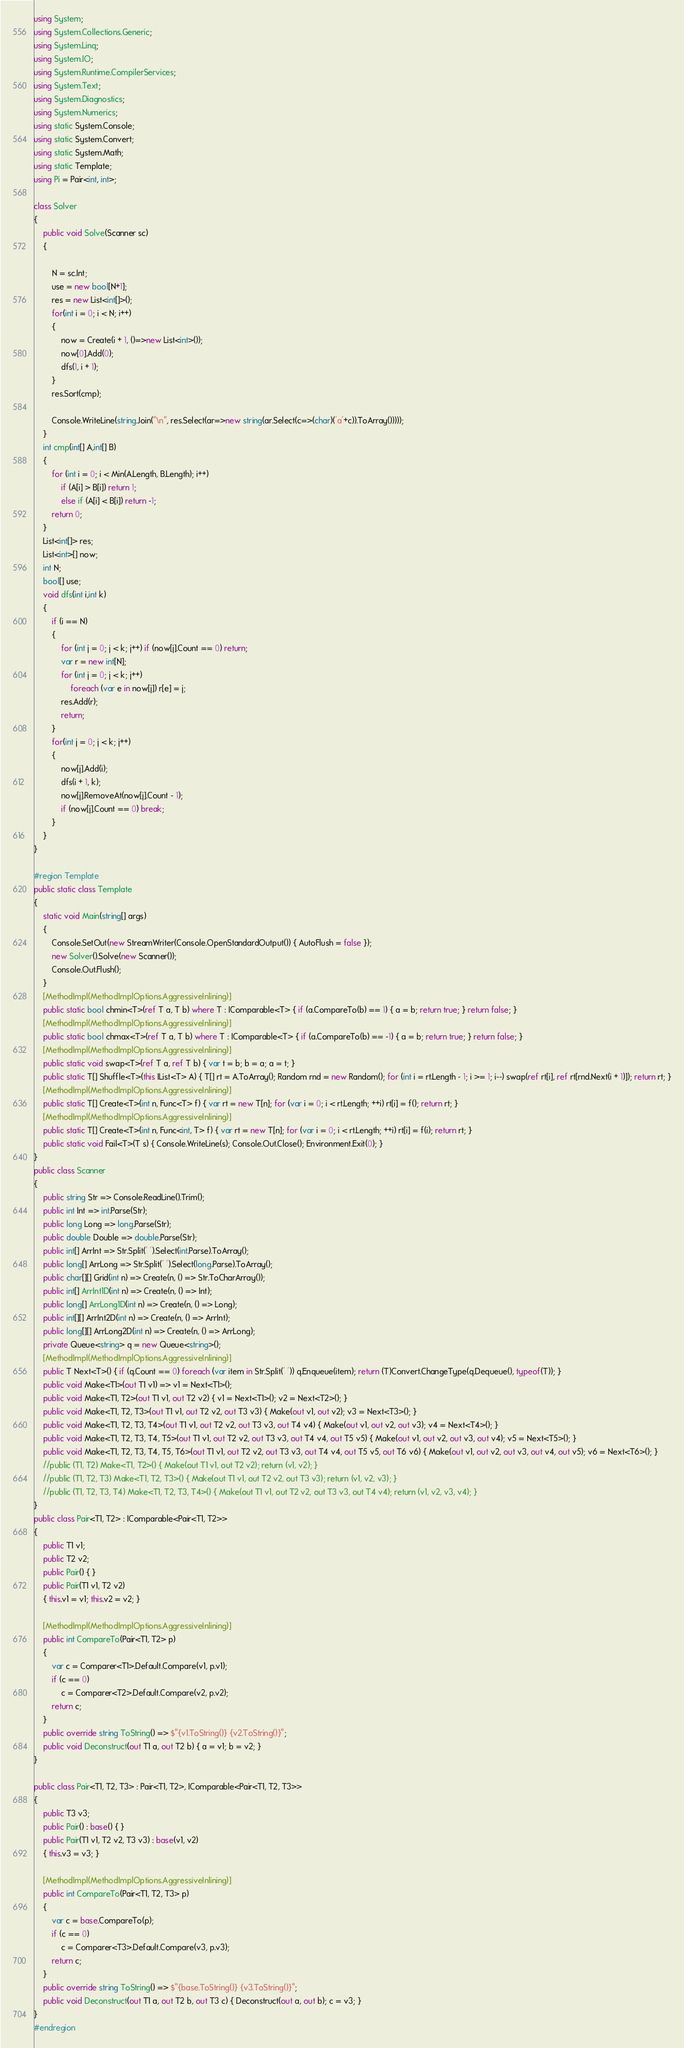Convert code to text. <code><loc_0><loc_0><loc_500><loc_500><_C#_>using System;
using System.Collections.Generic;
using System.Linq;
using System.IO;
using System.Runtime.CompilerServices;
using System.Text;
using System.Diagnostics;
using System.Numerics;
using static System.Console;
using static System.Convert;
using static System.Math;
using static Template;
using Pi = Pair<int, int>;

class Solver
{
    public void Solve(Scanner sc)
    {
        
        N = sc.Int;
        use = new bool[N+1];
        res = new List<int[]>();
        for(int i = 0; i < N; i++)
        {
            now = Create(i + 1, ()=>new List<int>());
            now[0].Add(0);
            dfs(1, i + 1);
        }
        res.Sort(cmp);

        Console.WriteLine(string.Join("\n", res.Select(ar=>new string(ar.Select(c=>(char)('a'+c)).ToArray()))));
    }
    int cmp(int[] A,int[] B)
    {
        for (int i = 0; i < Min(A.Length, B.Length); i++)
            if (A[i] > B[i]) return 1;
            else if (A[i] < B[i]) return -1;
        return 0;
    }
    List<int[]> res;
    List<int>[] now;
    int N;
    bool[] use;
    void dfs(int i,int k)
    {
        if (i == N)
        {
            for (int j = 0; j < k; j++) if (now[j].Count == 0) return;
            var r = new int[N];
            for (int j = 0; j < k; j++)
                foreach (var e in now[j]) r[e] = j;
            res.Add(r);
            return;
        }
        for(int j = 0; j < k; j++)
        {
            now[j].Add(i);
            dfs(i + 1, k);
            now[j].RemoveAt(now[j].Count - 1);
            if (now[j].Count == 0) break;
        }
    }
}

#region Template
public static class Template
{
    static void Main(string[] args)
    {
        Console.SetOut(new StreamWriter(Console.OpenStandardOutput()) { AutoFlush = false });
        new Solver().Solve(new Scanner());
        Console.Out.Flush();
    }
    [MethodImpl(MethodImplOptions.AggressiveInlining)]
    public static bool chmin<T>(ref T a, T b) where T : IComparable<T> { if (a.CompareTo(b) == 1) { a = b; return true; } return false; }
    [MethodImpl(MethodImplOptions.AggressiveInlining)]
    public static bool chmax<T>(ref T a, T b) where T : IComparable<T> { if (a.CompareTo(b) == -1) { a = b; return true; } return false; }
    [MethodImpl(MethodImplOptions.AggressiveInlining)]
    public static void swap<T>(ref T a, ref T b) { var t = b; b = a; a = t; }
    public static T[] Shuffle<T>(this IList<T> A) { T[] rt = A.ToArray(); Random rnd = new Random(); for (int i = rt.Length - 1; i >= 1; i--) swap(ref rt[i], ref rt[rnd.Next(i + 1)]); return rt; }
    [MethodImpl(MethodImplOptions.AggressiveInlining)]
    public static T[] Create<T>(int n, Func<T> f) { var rt = new T[n]; for (var i = 0; i < rt.Length; ++i) rt[i] = f(); return rt; }
    [MethodImpl(MethodImplOptions.AggressiveInlining)]
    public static T[] Create<T>(int n, Func<int, T> f) { var rt = new T[n]; for (var i = 0; i < rt.Length; ++i) rt[i] = f(i); return rt; }
    public static void Fail<T>(T s) { Console.WriteLine(s); Console.Out.Close(); Environment.Exit(0); }
}
public class Scanner
{
    public string Str => Console.ReadLine().Trim();
    public int Int => int.Parse(Str);
    public long Long => long.Parse(Str);
    public double Double => double.Parse(Str);
    public int[] ArrInt => Str.Split(' ').Select(int.Parse).ToArray();
    public long[] ArrLong => Str.Split(' ').Select(long.Parse).ToArray();
    public char[][] Grid(int n) => Create(n, () => Str.ToCharArray());
    public int[] ArrInt1D(int n) => Create(n, () => Int);
    public long[] ArrLong1D(int n) => Create(n, () => Long);
    public int[][] ArrInt2D(int n) => Create(n, () => ArrInt);
    public long[][] ArrLong2D(int n) => Create(n, () => ArrLong);
    private Queue<string> q = new Queue<string>();
    [MethodImpl(MethodImplOptions.AggressiveInlining)]
    public T Next<T>() { if (q.Count == 0) foreach (var item in Str.Split(' ')) q.Enqueue(item); return (T)Convert.ChangeType(q.Dequeue(), typeof(T)); }
    public void Make<T1>(out T1 v1) => v1 = Next<T1>();
    public void Make<T1, T2>(out T1 v1, out T2 v2) { v1 = Next<T1>(); v2 = Next<T2>(); }
    public void Make<T1, T2, T3>(out T1 v1, out T2 v2, out T3 v3) { Make(out v1, out v2); v3 = Next<T3>(); }
    public void Make<T1, T2, T3, T4>(out T1 v1, out T2 v2, out T3 v3, out T4 v4) { Make(out v1, out v2, out v3); v4 = Next<T4>(); }
    public void Make<T1, T2, T3, T4, T5>(out T1 v1, out T2 v2, out T3 v3, out T4 v4, out T5 v5) { Make(out v1, out v2, out v3, out v4); v5 = Next<T5>(); }
    public void Make<T1, T2, T3, T4, T5, T6>(out T1 v1, out T2 v2, out T3 v3, out T4 v4, out T5 v5, out T6 v6) { Make(out v1, out v2, out v3, out v4, out v5); v6 = Next<T6>(); }
    //public (T1, T2) Make<T1, T2>() { Make(out T1 v1, out T2 v2); return (v1, v2); }
    //public (T1, T2, T3) Make<T1, T2, T3>() { Make(out T1 v1, out T2 v2, out T3 v3); return (v1, v2, v3); }
    //public (T1, T2, T3, T4) Make<T1, T2, T3, T4>() { Make(out T1 v1, out T2 v2, out T3 v3, out T4 v4); return (v1, v2, v3, v4); }
}
public class Pair<T1, T2> : IComparable<Pair<T1, T2>>
{
    public T1 v1;
    public T2 v2;
    public Pair() { }
    public Pair(T1 v1, T2 v2)
    { this.v1 = v1; this.v2 = v2; }

    [MethodImpl(MethodImplOptions.AggressiveInlining)]
    public int CompareTo(Pair<T1, T2> p)
    {
        var c = Comparer<T1>.Default.Compare(v1, p.v1);
        if (c == 0)
            c = Comparer<T2>.Default.Compare(v2, p.v2);
        return c;
    }
    public override string ToString() => $"{v1.ToString()} {v2.ToString()}";
    public void Deconstruct(out T1 a, out T2 b) { a = v1; b = v2; }
}

public class Pair<T1, T2, T3> : Pair<T1, T2>, IComparable<Pair<T1, T2, T3>>
{
    public T3 v3;
    public Pair() : base() { }
    public Pair(T1 v1, T2 v2, T3 v3) : base(v1, v2)
    { this.v3 = v3; }

    [MethodImpl(MethodImplOptions.AggressiveInlining)]
    public int CompareTo(Pair<T1, T2, T3> p)
    {
        var c = base.CompareTo(p);
        if (c == 0)
            c = Comparer<T3>.Default.Compare(v3, p.v3);
        return c;
    }
    public override string ToString() => $"{base.ToString()} {v3.ToString()}";
    public void Deconstruct(out T1 a, out T2 b, out T3 c) { Deconstruct(out a, out b); c = v3; }
}
#endregion</code> 